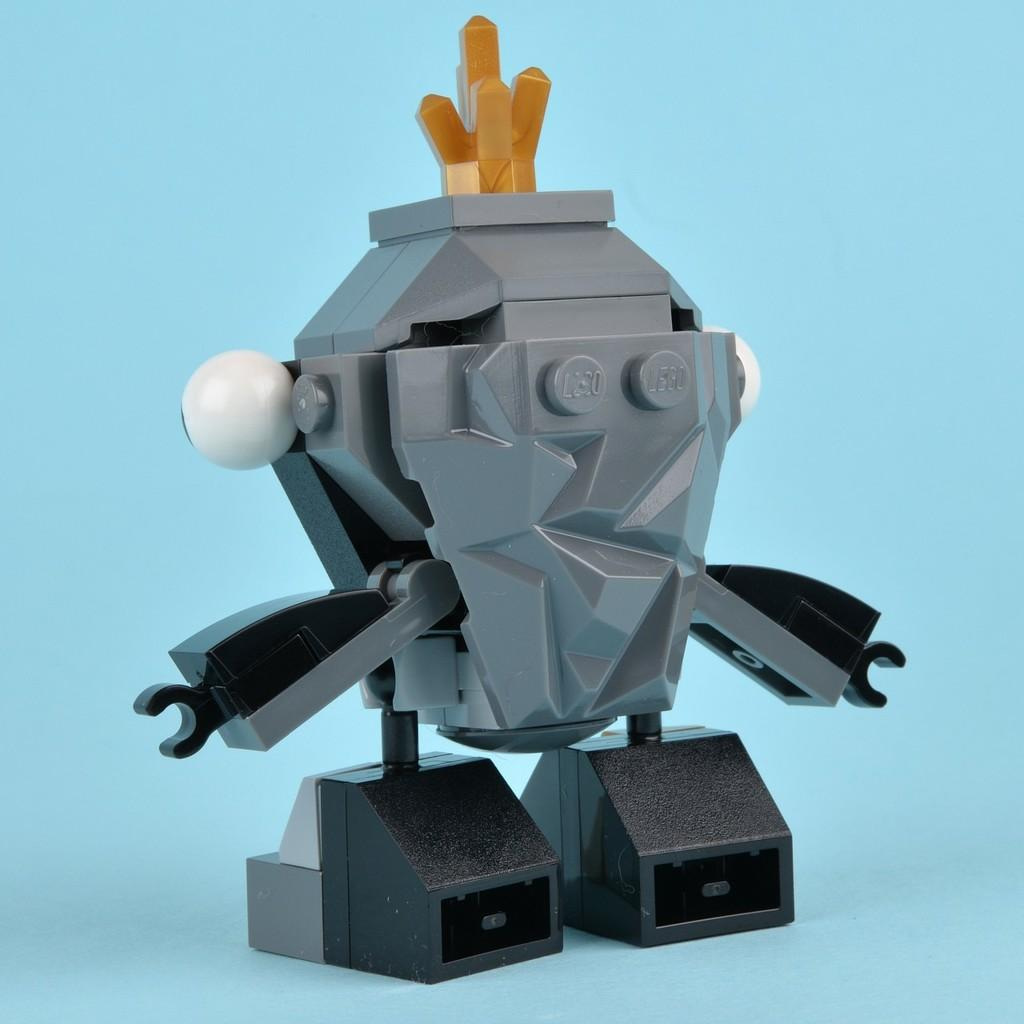What is the main subject in the middle of the image? There is a toy in the middle of the image. What type of kitty is responsible for maintaining peace in the image? There is no kitty or reference to peace in the image; it only features a toy. 